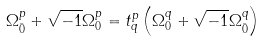<formula> <loc_0><loc_0><loc_500><loc_500>\Omega ^ { p } _ { \bar { 0 } } + \sqrt { - 1 } \Omega ^ { p } _ { 0 } = t ^ { p } _ { q } \left ( \Omega ^ { q } _ { 0 } + \sqrt { - 1 } \Omega ^ { q } _ { \bar { 0 } } \right )</formula> 